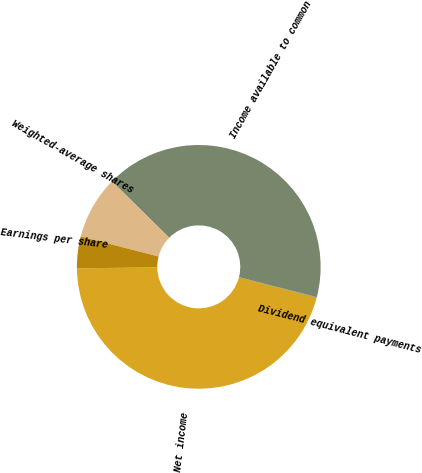<chart> <loc_0><loc_0><loc_500><loc_500><pie_chart><fcel>Net income<fcel>Dividend equivalent payments<fcel>Income available to common<fcel>Weighted-average shares<fcel>Earnings per share<nl><fcel>45.77%<fcel>0.04%<fcel>41.61%<fcel>8.37%<fcel>4.2%<nl></chart> 